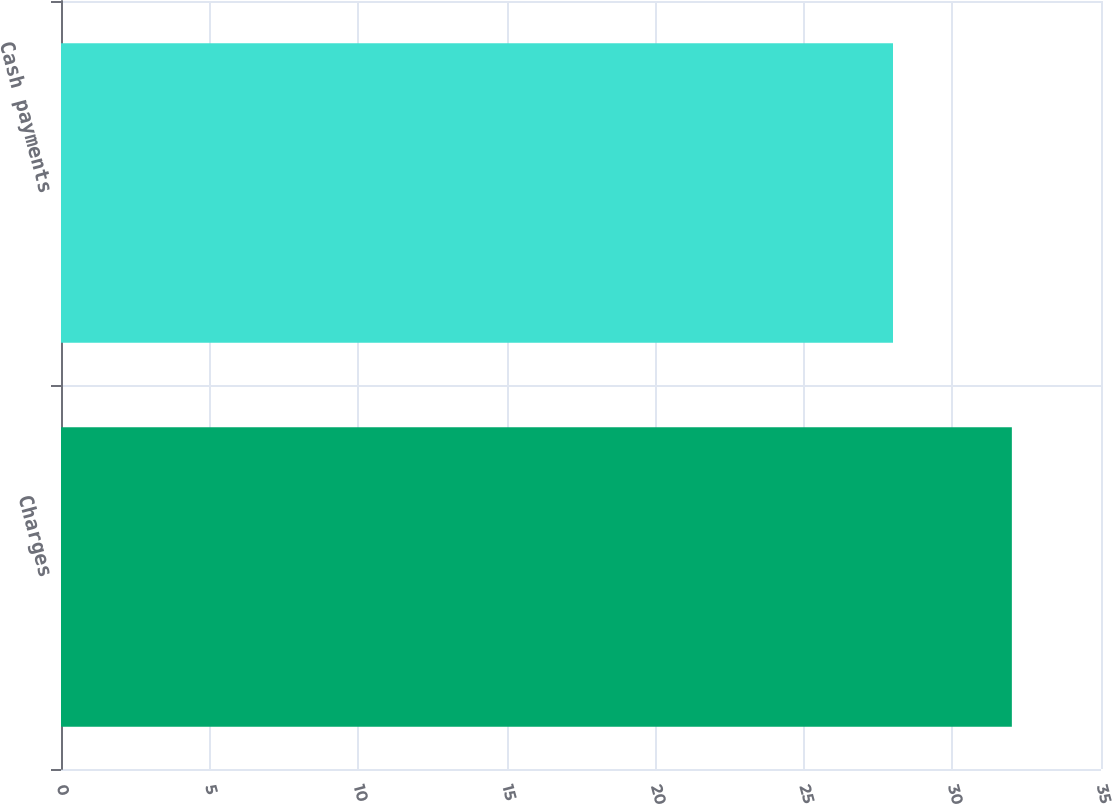Convert chart to OTSL. <chart><loc_0><loc_0><loc_500><loc_500><bar_chart><fcel>Charges<fcel>Cash payments<nl><fcel>32<fcel>28<nl></chart> 